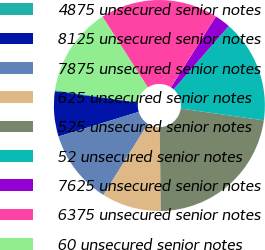<chart> <loc_0><loc_0><loc_500><loc_500><pie_chart><fcel>4875 unsecured senior notes<fcel>8125 unsecured senior notes<fcel>7875 unsecured senior notes<fcel>625 unsecured senior notes<fcel>525 unsecured senior notes<fcel>52 unsecured senior notes<fcel>7625 unsecured senior notes<fcel>6375 unsecured senior notes<fcel>60 unsecured senior notes<nl><fcel>0.18%<fcel>6.89%<fcel>11.36%<fcel>9.12%<fcel>22.54%<fcel>15.83%<fcel>2.42%<fcel>18.07%<fcel>13.6%<nl></chart> 